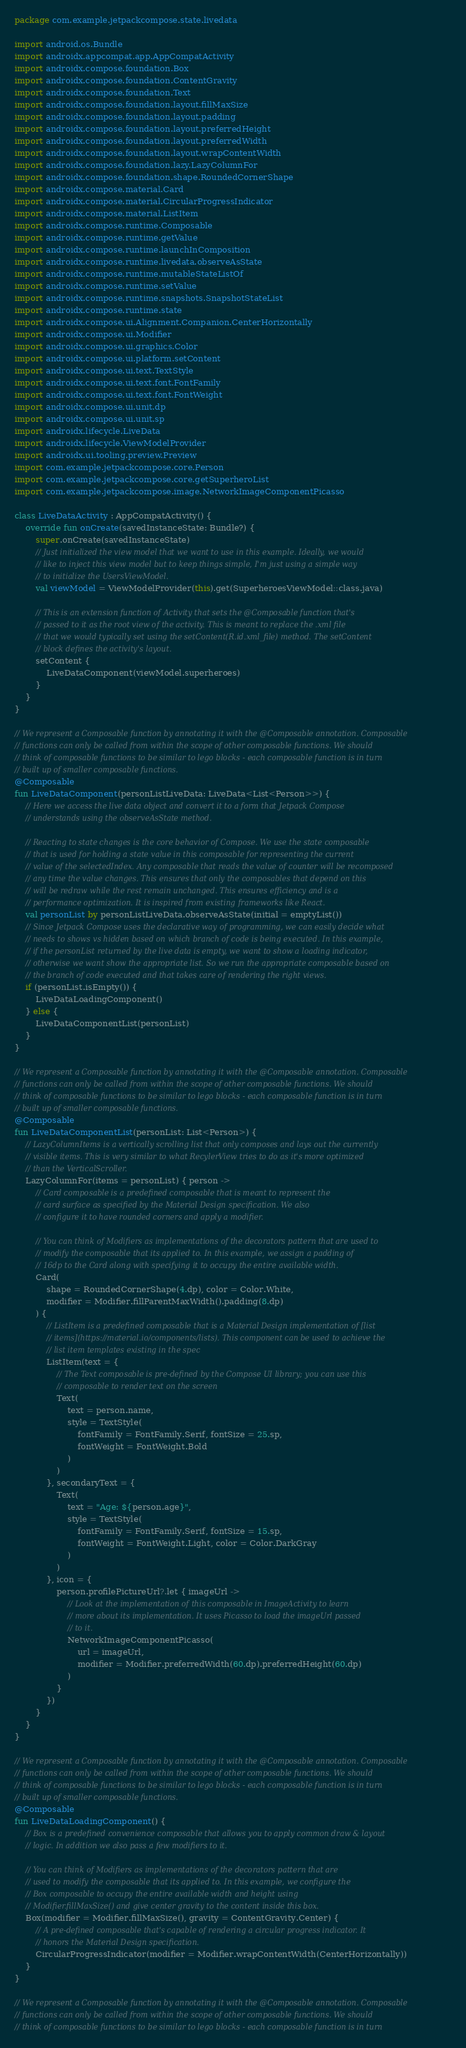Convert code to text. <code><loc_0><loc_0><loc_500><loc_500><_Kotlin_>package com.example.jetpackcompose.state.livedata

import android.os.Bundle
import androidx.appcompat.app.AppCompatActivity
import androidx.compose.foundation.Box
import androidx.compose.foundation.ContentGravity
import androidx.compose.foundation.Text
import androidx.compose.foundation.layout.fillMaxSize
import androidx.compose.foundation.layout.padding
import androidx.compose.foundation.layout.preferredHeight
import androidx.compose.foundation.layout.preferredWidth
import androidx.compose.foundation.layout.wrapContentWidth
import androidx.compose.foundation.lazy.LazyColumnFor
import androidx.compose.foundation.shape.RoundedCornerShape
import androidx.compose.material.Card
import androidx.compose.material.CircularProgressIndicator
import androidx.compose.material.ListItem
import androidx.compose.runtime.Composable
import androidx.compose.runtime.getValue
import androidx.compose.runtime.launchInComposition
import androidx.compose.runtime.livedata.observeAsState
import androidx.compose.runtime.mutableStateListOf
import androidx.compose.runtime.setValue
import androidx.compose.runtime.snapshots.SnapshotStateList
import androidx.compose.runtime.state
import androidx.compose.ui.Alignment.Companion.CenterHorizontally
import androidx.compose.ui.Modifier
import androidx.compose.ui.graphics.Color
import androidx.compose.ui.platform.setContent
import androidx.compose.ui.text.TextStyle
import androidx.compose.ui.text.font.FontFamily
import androidx.compose.ui.text.font.FontWeight
import androidx.compose.ui.unit.dp
import androidx.compose.ui.unit.sp
import androidx.lifecycle.LiveData
import androidx.lifecycle.ViewModelProvider
import androidx.ui.tooling.preview.Preview
import com.example.jetpackcompose.core.Person
import com.example.jetpackcompose.core.getSuperheroList
import com.example.jetpackcompose.image.NetworkImageComponentPicasso

class LiveDataActivity : AppCompatActivity() {
    override fun onCreate(savedInstanceState: Bundle?) {
        super.onCreate(savedInstanceState)
        // Just initialized the view model that we want to use in this example. Ideally, we would
        // like to inject this view model but to keep things simple, I'm just using a simple way
        // to initialize the UsersViewModel.
        val viewModel = ViewModelProvider(this).get(SuperheroesViewModel::class.java)

        // This is an extension function of Activity that sets the @Composable function that's
        // passed to it as the root view of the activity. This is meant to replace the .xml file
        // that we would typically set using the setContent(R.id.xml_file) method. The setContent
        // block defines the activity's layout.
        setContent {
            LiveDataComponent(viewModel.superheroes)
        }
    }
}

// We represent a Composable function by annotating it with the @Composable annotation. Composable
// functions can only be called from within the scope of other composable functions. We should
// think of composable functions to be similar to lego blocks - each composable function is in turn
// built up of smaller composable functions.
@Composable
fun LiveDataComponent(personListLiveData: LiveData<List<Person>>) {
    // Here we access the live data object and convert it to a form that Jetpack Compose 
    // understands using the observeAsState method. 

    // Reacting to state changes is the core behavior of Compose. We use the state composable
    // that is used for holding a state value in this composable for representing the current
    // value of the selectedIndex. Any composable that reads the value of counter will be recomposed
    // any time the value changes. This ensures that only the composables that depend on this
    // will be redraw while the rest remain unchanged. This ensures efficiency and is a
    // performance optimization. It is inspired from existing frameworks like React.
    val personList by personListLiveData.observeAsState(initial = emptyList())
    // Since Jetpack Compose uses the declarative way of programming, we can easily decide what
    // needs to shows vs hidden based on which branch of code is being executed. In this example,
    // if the personList returned by the live data is empty, we want to show a loading indicator,
    // otherwise we want show the appropriate list. So we run the appropriate composable based on
    // the branch of code executed and that takes care of rendering the right views.
    if (personList.isEmpty()) {
        LiveDataLoadingComponent()
    } else {
        LiveDataComponentList(personList)
    }
}

// We represent a Composable function by annotating it with the @Composable annotation. Composable
// functions can only be called from within the scope of other composable functions. We should
// think of composable functions to be similar to lego blocks - each composable function is in turn
// built up of smaller composable functions.
@Composable
fun LiveDataComponentList(personList: List<Person>) {
    // LazyColumnItems is a vertically scrolling list that only composes and lays out the currently
    // visible items. This is very similar to what RecylerView tries to do as it's more optimized
    // than the VerticalScroller.
    LazyColumnFor(items = personList) { person ->
        // Card composable is a predefined composable that is meant to represent the
        // card surface as specified by the Material Design specification. We also
        // configure it to have rounded corners and apply a modifier.

        // You can think of Modifiers as implementations of the decorators pattern that are used to
        // modify the composable that its applied to. In this example, we assign a padding of
        // 16dp to the Card along with specifying it to occupy the entire available width.
        Card(
            shape = RoundedCornerShape(4.dp), color = Color.White,
            modifier = Modifier.fillParentMaxWidth().padding(8.dp)
        ) {
            // ListItem is a predefined composable that is a Material Design implementation of [list
            // items](https://material.io/components/lists). This component can be used to achieve the
            // list item templates existing in the spec
            ListItem(text = {
                // The Text composable is pre-defined by the Compose UI library; you can use this
                // composable to render text on the screen
                Text(
                    text = person.name,
                    style = TextStyle(
                        fontFamily = FontFamily.Serif, fontSize = 25.sp,
                        fontWeight = FontWeight.Bold
                    )
                )
            }, secondaryText = {
                Text(
                    text = "Age: ${person.age}",
                    style = TextStyle(
                        fontFamily = FontFamily.Serif, fontSize = 15.sp,
                        fontWeight = FontWeight.Light, color = Color.DarkGray
                    )
                )
            }, icon = {
                person.profilePictureUrl?.let { imageUrl ->
                    // Look at the implementation of this composable in ImageActivity to learn
                    // more about its implementation. It uses Picasso to load the imageUrl passed
                    // to it.
                    NetworkImageComponentPicasso(
                        url = imageUrl,
                        modifier = Modifier.preferredWidth(60.dp).preferredHeight(60.dp)
                    )
                }
            })
        }
    }
}

// We represent a Composable function by annotating it with the @Composable annotation. Composable
// functions can only be called from within the scope of other composable functions. We should
// think of composable functions to be similar to lego blocks - each composable function is in turn
// built up of smaller composable functions.
@Composable
fun LiveDataLoadingComponent() {
    // Box is a predefined convenience composable that allows you to apply common draw & layout
    // logic. In addition we also pass a few modifiers to it.

    // You can think of Modifiers as implementations of the decorators pattern that are
    // used to modify the composable that its applied to. In this example, we configure the
    // Box composable to occupy the entire available width and height using
    // Modifier.fillMaxSize() and give center gravity to the content inside this box.
    Box(modifier = Modifier.fillMaxSize(), gravity = ContentGravity.Center) {
        // A pre-defined composable that's capable of rendering a circular progress indicator. It
        // honors the Material Design specification.
        CircularProgressIndicator(modifier = Modifier.wrapContentWidth(CenterHorizontally))
    }
}

// We represent a Composable function by annotating it with the @Composable annotation. Composable
// functions can only be called from within the scope of other composable functions. We should 
// think of composable functions to be similar to lego blocks - each composable function is in turn </code> 